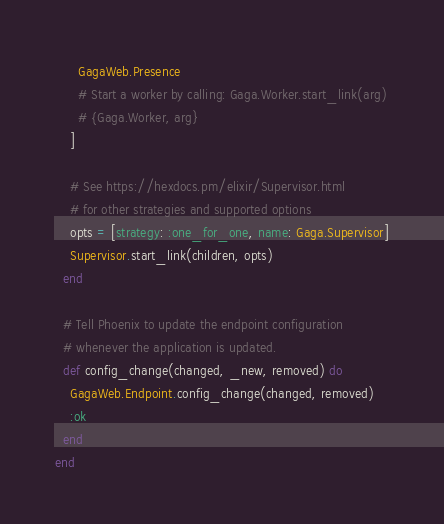<code> <loc_0><loc_0><loc_500><loc_500><_Elixir_>      GagaWeb.Presence
      # Start a worker by calling: Gaga.Worker.start_link(arg)
      # {Gaga.Worker, arg}
    ]

    # See https://hexdocs.pm/elixir/Supervisor.html
    # for other strategies and supported options
    opts = [strategy: :one_for_one, name: Gaga.Supervisor]
    Supervisor.start_link(children, opts)
  end

  # Tell Phoenix to update the endpoint configuration
  # whenever the application is updated.
  def config_change(changed, _new, removed) do
    GagaWeb.Endpoint.config_change(changed, removed)
    :ok
  end
end
</code> 